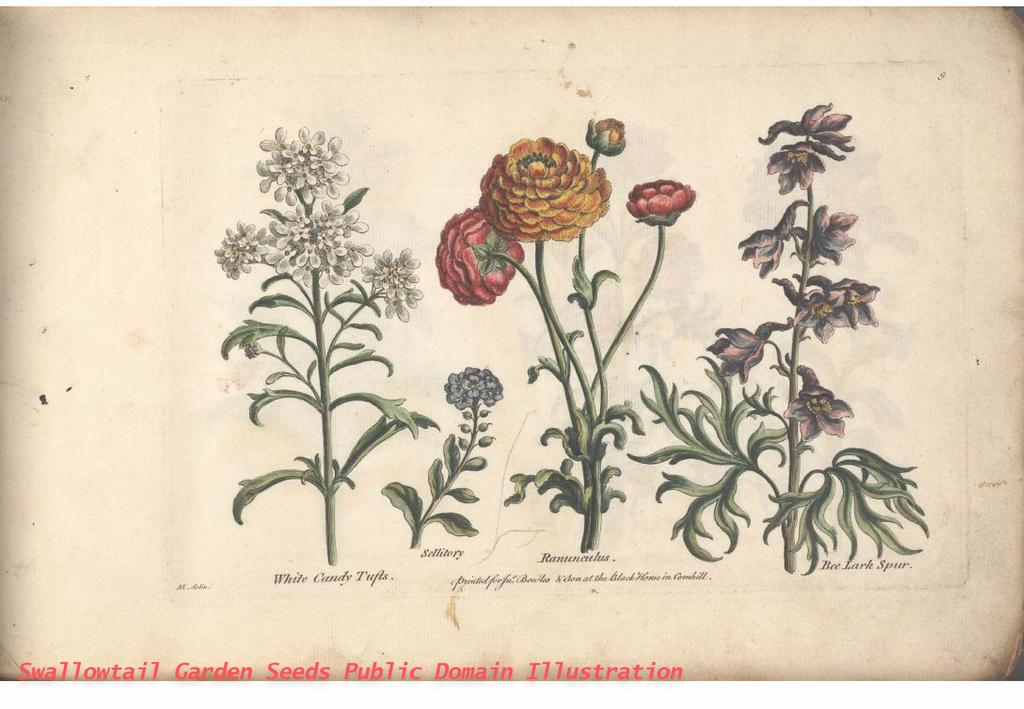What type of visual is the image? The image is a poster. What natural elements are depicted on the poster? There are flowers, branches, and leaves on the poster. What type of church can be seen in the background of the poster? There is no church present in the image; it is a poster featuring flowers, branches, and leaves. What type of cushion is placed on the leaves in the image? There is no cushion present in the image; it only features flowers, branches, and leaves. 